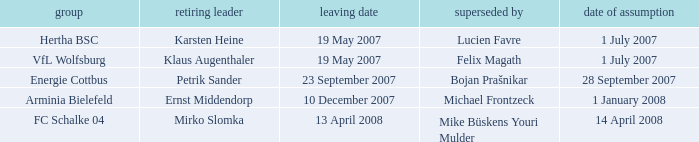When was the departure date when a manager was replaced by Bojan Prašnikar? 23 September 2007. 